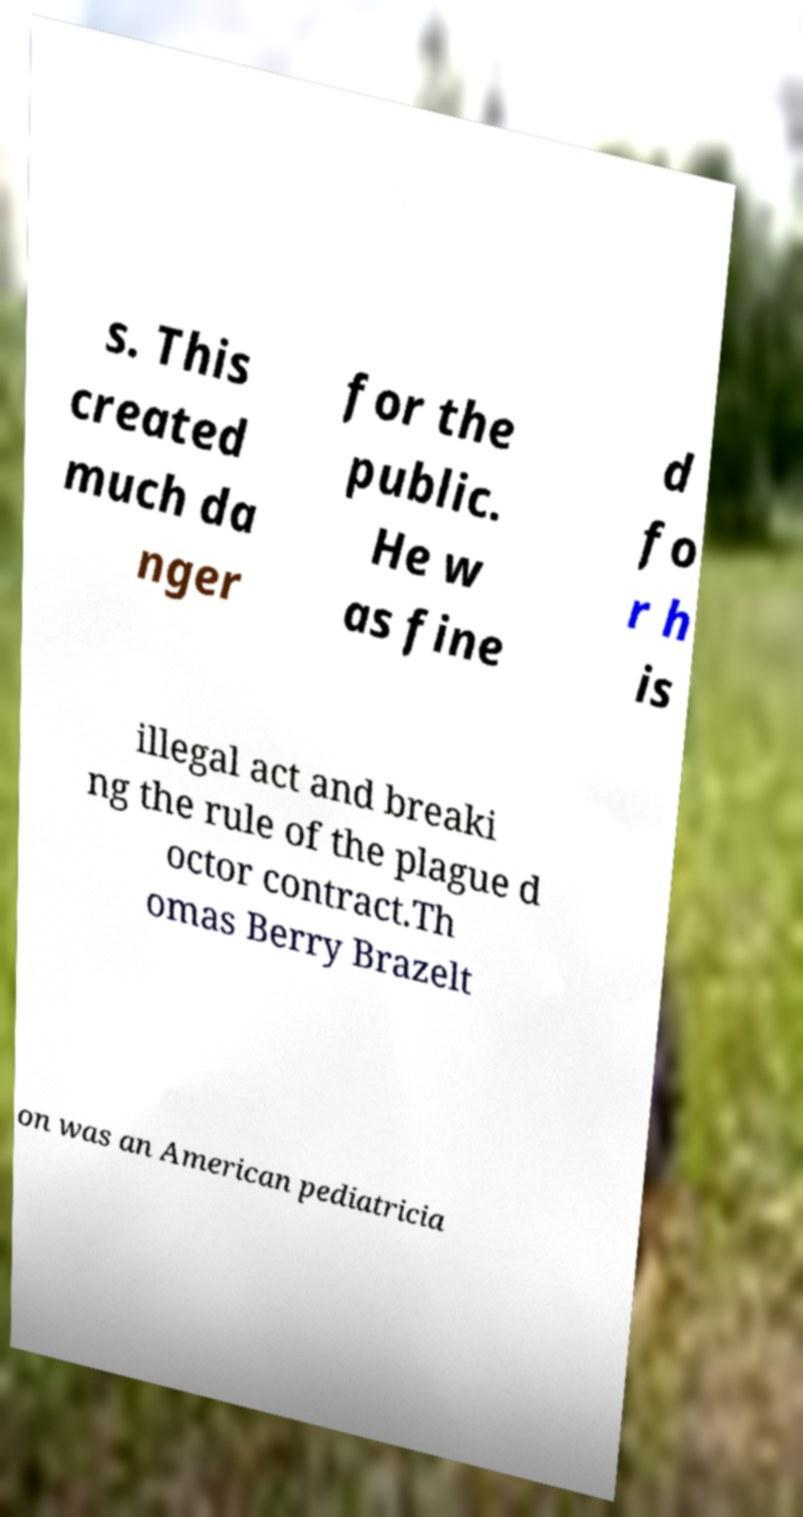Can you accurately transcribe the text from the provided image for me? s. This created much da nger for the public. He w as fine d fo r h is illegal act and breaki ng the rule of the plague d octor contract.Th omas Berry Brazelt on was an American pediatricia 